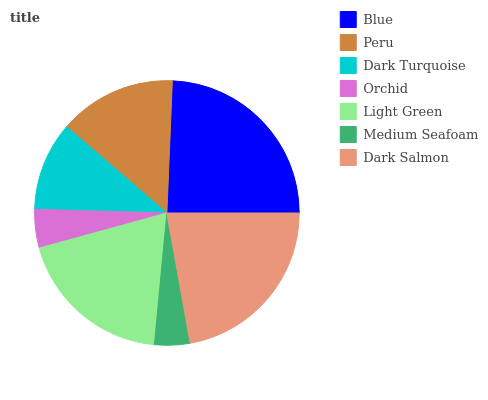Is Medium Seafoam the minimum?
Answer yes or no. Yes. Is Blue the maximum?
Answer yes or no. Yes. Is Peru the minimum?
Answer yes or no. No. Is Peru the maximum?
Answer yes or no. No. Is Blue greater than Peru?
Answer yes or no. Yes. Is Peru less than Blue?
Answer yes or no. Yes. Is Peru greater than Blue?
Answer yes or no. No. Is Blue less than Peru?
Answer yes or no. No. Is Peru the high median?
Answer yes or no. Yes. Is Peru the low median?
Answer yes or no. Yes. Is Medium Seafoam the high median?
Answer yes or no. No. Is Dark Turquoise the low median?
Answer yes or no. No. 